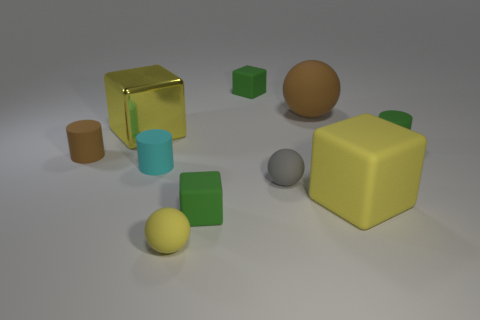Subtract all large balls. How many balls are left? 2 Subtract all yellow cylinders. How many yellow cubes are left? 2 Subtract all cubes. How many objects are left? 6 Subtract 1 cylinders. How many cylinders are left? 2 Add 4 metallic blocks. How many metallic blocks exist? 5 Subtract 0 purple cylinders. How many objects are left? 10 Subtract all blue cubes. Subtract all cyan balls. How many cubes are left? 4 Subtract all green cubes. Subtract all small green cylinders. How many objects are left? 7 Add 3 large shiny cubes. How many large shiny cubes are left? 4 